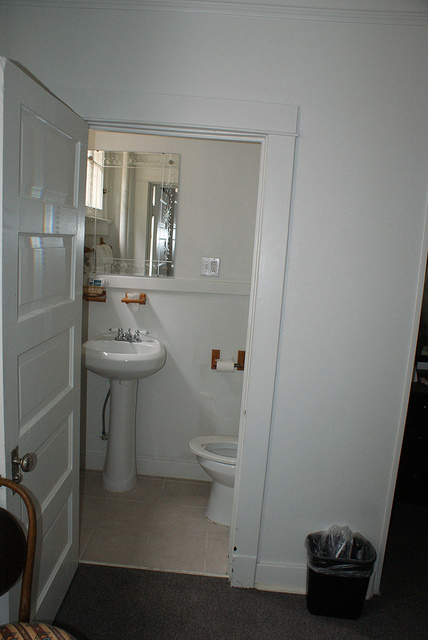<image>Why are there items on the self? It is unknown why there are items on the shelf. They could be there for a variety of reasons such as storage, organization or easy reach. Why are there items on the self? There can be different reasons why there are items on the shelf. It can be for storage, to use, or to stay organized. 